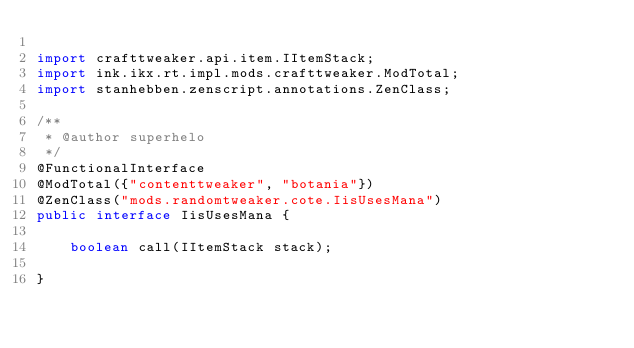<code> <loc_0><loc_0><loc_500><loc_500><_Java_>
import crafttweaker.api.item.IItemStack;
import ink.ikx.rt.impl.mods.crafttweaker.ModTotal;
import stanhebben.zenscript.annotations.ZenClass;

/**
 * @author superhelo
 */
@FunctionalInterface
@ModTotal({"contenttweaker", "botania"})
@ZenClass("mods.randomtweaker.cote.IisUsesMana")
public interface IisUsesMana {

    boolean call(IItemStack stack);

}
</code> 